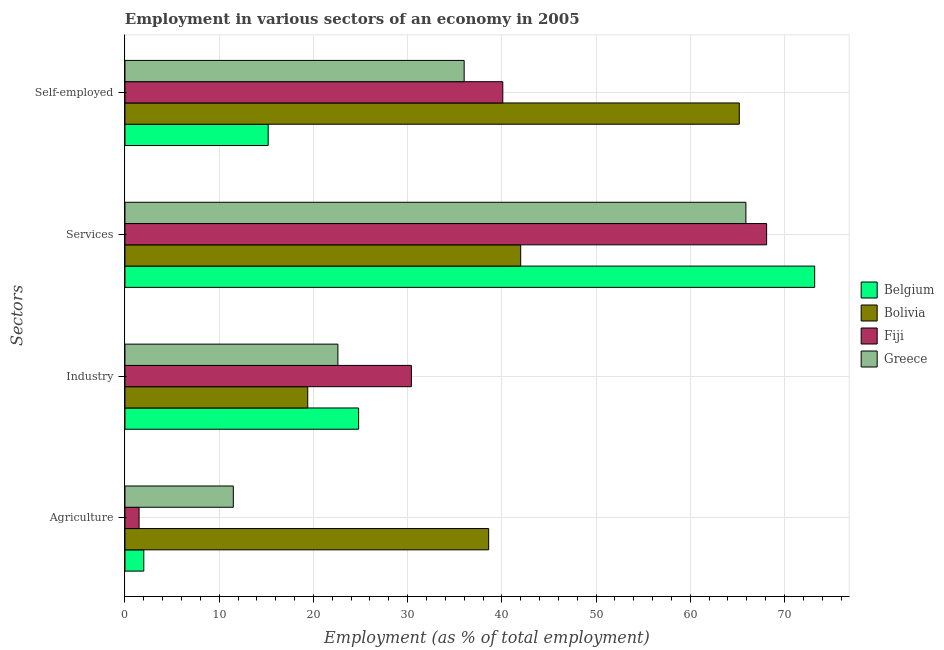Are the number of bars on each tick of the Y-axis equal?
Provide a succinct answer. Yes. How many bars are there on the 2nd tick from the top?
Ensure brevity in your answer.  4. What is the label of the 2nd group of bars from the top?
Your response must be concise. Services. What is the percentage of workers in industry in Greece?
Your response must be concise. 22.6. Across all countries, what is the maximum percentage of workers in industry?
Your response must be concise. 30.4. In which country was the percentage of workers in industry maximum?
Your response must be concise. Fiji. In which country was the percentage of workers in agriculture minimum?
Provide a short and direct response. Fiji. What is the total percentage of workers in agriculture in the graph?
Ensure brevity in your answer.  53.6. What is the difference between the percentage of self employed workers in Bolivia and that in Greece?
Offer a very short reply. 29.2. What is the difference between the percentage of workers in industry in Belgium and the percentage of workers in services in Fiji?
Keep it short and to the point. -43.3. What is the average percentage of workers in services per country?
Your response must be concise. 62.3. What is the difference between the percentage of workers in industry and percentage of self employed workers in Bolivia?
Ensure brevity in your answer.  -45.8. What is the ratio of the percentage of workers in industry in Bolivia to that in Greece?
Keep it short and to the point. 0.86. What is the difference between the highest and the second highest percentage of workers in services?
Give a very brief answer. 5.1. What is the difference between the highest and the lowest percentage of workers in agriculture?
Your answer should be compact. 37.1. In how many countries, is the percentage of workers in agriculture greater than the average percentage of workers in agriculture taken over all countries?
Ensure brevity in your answer.  1. Is the sum of the percentage of self employed workers in Greece and Bolivia greater than the maximum percentage of workers in services across all countries?
Keep it short and to the point. Yes. Is it the case that in every country, the sum of the percentage of workers in agriculture and percentage of workers in industry is greater than the sum of percentage of self employed workers and percentage of workers in services?
Keep it short and to the point. No. What does the 3rd bar from the bottom in Self-employed represents?
Ensure brevity in your answer.  Fiji. Are the values on the major ticks of X-axis written in scientific E-notation?
Give a very brief answer. No. Does the graph contain any zero values?
Your answer should be compact. No. Where does the legend appear in the graph?
Offer a very short reply. Center right. What is the title of the graph?
Provide a succinct answer. Employment in various sectors of an economy in 2005. Does "Puerto Rico" appear as one of the legend labels in the graph?
Make the answer very short. No. What is the label or title of the X-axis?
Keep it short and to the point. Employment (as % of total employment). What is the label or title of the Y-axis?
Provide a short and direct response. Sectors. What is the Employment (as % of total employment) in Bolivia in Agriculture?
Make the answer very short. 38.6. What is the Employment (as % of total employment) of Belgium in Industry?
Give a very brief answer. 24.8. What is the Employment (as % of total employment) of Bolivia in Industry?
Offer a terse response. 19.4. What is the Employment (as % of total employment) in Fiji in Industry?
Keep it short and to the point. 30.4. What is the Employment (as % of total employment) of Greece in Industry?
Provide a succinct answer. 22.6. What is the Employment (as % of total employment) in Belgium in Services?
Provide a succinct answer. 73.2. What is the Employment (as % of total employment) in Bolivia in Services?
Your response must be concise. 42. What is the Employment (as % of total employment) of Fiji in Services?
Your answer should be compact. 68.1. What is the Employment (as % of total employment) in Greece in Services?
Provide a short and direct response. 65.9. What is the Employment (as % of total employment) in Belgium in Self-employed?
Your response must be concise. 15.2. What is the Employment (as % of total employment) in Bolivia in Self-employed?
Your answer should be very brief. 65.2. What is the Employment (as % of total employment) in Fiji in Self-employed?
Ensure brevity in your answer.  40.1. Across all Sectors, what is the maximum Employment (as % of total employment) in Belgium?
Your response must be concise. 73.2. Across all Sectors, what is the maximum Employment (as % of total employment) in Bolivia?
Your response must be concise. 65.2. Across all Sectors, what is the maximum Employment (as % of total employment) of Fiji?
Offer a terse response. 68.1. Across all Sectors, what is the maximum Employment (as % of total employment) of Greece?
Your answer should be compact. 65.9. Across all Sectors, what is the minimum Employment (as % of total employment) in Belgium?
Ensure brevity in your answer.  2. Across all Sectors, what is the minimum Employment (as % of total employment) in Bolivia?
Your answer should be very brief. 19.4. Across all Sectors, what is the minimum Employment (as % of total employment) in Fiji?
Provide a succinct answer. 1.5. Across all Sectors, what is the minimum Employment (as % of total employment) of Greece?
Make the answer very short. 11.5. What is the total Employment (as % of total employment) of Belgium in the graph?
Offer a very short reply. 115.2. What is the total Employment (as % of total employment) in Bolivia in the graph?
Keep it short and to the point. 165.2. What is the total Employment (as % of total employment) of Fiji in the graph?
Make the answer very short. 140.1. What is the total Employment (as % of total employment) of Greece in the graph?
Your answer should be compact. 136. What is the difference between the Employment (as % of total employment) of Belgium in Agriculture and that in Industry?
Provide a short and direct response. -22.8. What is the difference between the Employment (as % of total employment) of Fiji in Agriculture and that in Industry?
Your answer should be compact. -28.9. What is the difference between the Employment (as % of total employment) of Greece in Agriculture and that in Industry?
Your response must be concise. -11.1. What is the difference between the Employment (as % of total employment) of Belgium in Agriculture and that in Services?
Your answer should be compact. -71.2. What is the difference between the Employment (as % of total employment) in Bolivia in Agriculture and that in Services?
Offer a terse response. -3.4. What is the difference between the Employment (as % of total employment) of Fiji in Agriculture and that in Services?
Give a very brief answer. -66.6. What is the difference between the Employment (as % of total employment) in Greece in Agriculture and that in Services?
Provide a succinct answer. -54.4. What is the difference between the Employment (as % of total employment) in Belgium in Agriculture and that in Self-employed?
Keep it short and to the point. -13.2. What is the difference between the Employment (as % of total employment) in Bolivia in Agriculture and that in Self-employed?
Provide a succinct answer. -26.6. What is the difference between the Employment (as % of total employment) in Fiji in Agriculture and that in Self-employed?
Make the answer very short. -38.6. What is the difference between the Employment (as % of total employment) in Greece in Agriculture and that in Self-employed?
Offer a very short reply. -24.5. What is the difference between the Employment (as % of total employment) in Belgium in Industry and that in Services?
Make the answer very short. -48.4. What is the difference between the Employment (as % of total employment) in Bolivia in Industry and that in Services?
Your answer should be compact. -22.6. What is the difference between the Employment (as % of total employment) in Fiji in Industry and that in Services?
Give a very brief answer. -37.7. What is the difference between the Employment (as % of total employment) of Greece in Industry and that in Services?
Your answer should be compact. -43.3. What is the difference between the Employment (as % of total employment) of Bolivia in Industry and that in Self-employed?
Offer a terse response. -45.8. What is the difference between the Employment (as % of total employment) in Greece in Industry and that in Self-employed?
Give a very brief answer. -13.4. What is the difference between the Employment (as % of total employment) of Bolivia in Services and that in Self-employed?
Your response must be concise. -23.2. What is the difference between the Employment (as % of total employment) in Greece in Services and that in Self-employed?
Your response must be concise. 29.9. What is the difference between the Employment (as % of total employment) in Belgium in Agriculture and the Employment (as % of total employment) in Bolivia in Industry?
Offer a terse response. -17.4. What is the difference between the Employment (as % of total employment) of Belgium in Agriculture and the Employment (as % of total employment) of Fiji in Industry?
Give a very brief answer. -28.4. What is the difference between the Employment (as % of total employment) in Belgium in Agriculture and the Employment (as % of total employment) in Greece in Industry?
Your response must be concise. -20.6. What is the difference between the Employment (as % of total employment) of Fiji in Agriculture and the Employment (as % of total employment) of Greece in Industry?
Keep it short and to the point. -21.1. What is the difference between the Employment (as % of total employment) of Belgium in Agriculture and the Employment (as % of total employment) of Bolivia in Services?
Ensure brevity in your answer.  -40. What is the difference between the Employment (as % of total employment) of Belgium in Agriculture and the Employment (as % of total employment) of Fiji in Services?
Offer a terse response. -66.1. What is the difference between the Employment (as % of total employment) of Belgium in Agriculture and the Employment (as % of total employment) of Greece in Services?
Your response must be concise. -63.9. What is the difference between the Employment (as % of total employment) of Bolivia in Agriculture and the Employment (as % of total employment) of Fiji in Services?
Make the answer very short. -29.5. What is the difference between the Employment (as % of total employment) of Bolivia in Agriculture and the Employment (as % of total employment) of Greece in Services?
Your answer should be very brief. -27.3. What is the difference between the Employment (as % of total employment) of Fiji in Agriculture and the Employment (as % of total employment) of Greece in Services?
Offer a terse response. -64.4. What is the difference between the Employment (as % of total employment) of Belgium in Agriculture and the Employment (as % of total employment) of Bolivia in Self-employed?
Your response must be concise. -63.2. What is the difference between the Employment (as % of total employment) of Belgium in Agriculture and the Employment (as % of total employment) of Fiji in Self-employed?
Your answer should be compact. -38.1. What is the difference between the Employment (as % of total employment) in Belgium in Agriculture and the Employment (as % of total employment) in Greece in Self-employed?
Give a very brief answer. -34. What is the difference between the Employment (as % of total employment) in Fiji in Agriculture and the Employment (as % of total employment) in Greece in Self-employed?
Offer a very short reply. -34.5. What is the difference between the Employment (as % of total employment) of Belgium in Industry and the Employment (as % of total employment) of Bolivia in Services?
Offer a terse response. -17.2. What is the difference between the Employment (as % of total employment) in Belgium in Industry and the Employment (as % of total employment) in Fiji in Services?
Provide a succinct answer. -43.3. What is the difference between the Employment (as % of total employment) of Belgium in Industry and the Employment (as % of total employment) of Greece in Services?
Provide a succinct answer. -41.1. What is the difference between the Employment (as % of total employment) in Bolivia in Industry and the Employment (as % of total employment) in Fiji in Services?
Ensure brevity in your answer.  -48.7. What is the difference between the Employment (as % of total employment) in Bolivia in Industry and the Employment (as % of total employment) in Greece in Services?
Make the answer very short. -46.5. What is the difference between the Employment (as % of total employment) of Fiji in Industry and the Employment (as % of total employment) of Greece in Services?
Your answer should be compact. -35.5. What is the difference between the Employment (as % of total employment) in Belgium in Industry and the Employment (as % of total employment) in Bolivia in Self-employed?
Your response must be concise. -40.4. What is the difference between the Employment (as % of total employment) in Belgium in Industry and the Employment (as % of total employment) in Fiji in Self-employed?
Make the answer very short. -15.3. What is the difference between the Employment (as % of total employment) in Bolivia in Industry and the Employment (as % of total employment) in Fiji in Self-employed?
Offer a very short reply. -20.7. What is the difference between the Employment (as % of total employment) of Bolivia in Industry and the Employment (as % of total employment) of Greece in Self-employed?
Your answer should be very brief. -16.6. What is the difference between the Employment (as % of total employment) of Belgium in Services and the Employment (as % of total employment) of Fiji in Self-employed?
Ensure brevity in your answer.  33.1. What is the difference between the Employment (as % of total employment) in Belgium in Services and the Employment (as % of total employment) in Greece in Self-employed?
Your response must be concise. 37.2. What is the difference between the Employment (as % of total employment) in Bolivia in Services and the Employment (as % of total employment) in Greece in Self-employed?
Offer a very short reply. 6. What is the difference between the Employment (as % of total employment) of Fiji in Services and the Employment (as % of total employment) of Greece in Self-employed?
Your answer should be compact. 32.1. What is the average Employment (as % of total employment) of Belgium per Sectors?
Your response must be concise. 28.8. What is the average Employment (as % of total employment) of Bolivia per Sectors?
Your answer should be compact. 41.3. What is the average Employment (as % of total employment) of Fiji per Sectors?
Ensure brevity in your answer.  35.02. What is the average Employment (as % of total employment) in Greece per Sectors?
Keep it short and to the point. 34. What is the difference between the Employment (as % of total employment) in Belgium and Employment (as % of total employment) in Bolivia in Agriculture?
Offer a terse response. -36.6. What is the difference between the Employment (as % of total employment) of Belgium and Employment (as % of total employment) of Fiji in Agriculture?
Offer a very short reply. 0.5. What is the difference between the Employment (as % of total employment) in Belgium and Employment (as % of total employment) in Greece in Agriculture?
Your answer should be very brief. -9.5. What is the difference between the Employment (as % of total employment) in Bolivia and Employment (as % of total employment) in Fiji in Agriculture?
Keep it short and to the point. 37.1. What is the difference between the Employment (as % of total employment) of Bolivia and Employment (as % of total employment) of Greece in Agriculture?
Your answer should be compact. 27.1. What is the difference between the Employment (as % of total employment) in Bolivia and Employment (as % of total employment) in Greece in Industry?
Your answer should be compact. -3.2. What is the difference between the Employment (as % of total employment) of Fiji and Employment (as % of total employment) of Greece in Industry?
Keep it short and to the point. 7.8. What is the difference between the Employment (as % of total employment) in Belgium and Employment (as % of total employment) in Bolivia in Services?
Offer a very short reply. 31.2. What is the difference between the Employment (as % of total employment) in Belgium and Employment (as % of total employment) in Greece in Services?
Give a very brief answer. 7.3. What is the difference between the Employment (as % of total employment) of Bolivia and Employment (as % of total employment) of Fiji in Services?
Offer a terse response. -26.1. What is the difference between the Employment (as % of total employment) in Bolivia and Employment (as % of total employment) in Greece in Services?
Your answer should be very brief. -23.9. What is the difference between the Employment (as % of total employment) of Fiji and Employment (as % of total employment) of Greece in Services?
Keep it short and to the point. 2.2. What is the difference between the Employment (as % of total employment) of Belgium and Employment (as % of total employment) of Fiji in Self-employed?
Ensure brevity in your answer.  -24.9. What is the difference between the Employment (as % of total employment) of Belgium and Employment (as % of total employment) of Greece in Self-employed?
Your response must be concise. -20.8. What is the difference between the Employment (as % of total employment) in Bolivia and Employment (as % of total employment) in Fiji in Self-employed?
Your answer should be compact. 25.1. What is the difference between the Employment (as % of total employment) in Bolivia and Employment (as % of total employment) in Greece in Self-employed?
Give a very brief answer. 29.2. What is the difference between the Employment (as % of total employment) of Fiji and Employment (as % of total employment) of Greece in Self-employed?
Give a very brief answer. 4.1. What is the ratio of the Employment (as % of total employment) of Belgium in Agriculture to that in Industry?
Offer a terse response. 0.08. What is the ratio of the Employment (as % of total employment) in Bolivia in Agriculture to that in Industry?
Give a very brief answer. 1.99. What is the ratio of the Employment (as % of total employment) in Fiji in Agriculture to that in Industry?
Keep it short and to the point. 0.05. What is the ratio of the Employment (as % of total employment) of Greece in Agriculture to that in Industry?
Your answer should be compact. 0.51. What is the ratio of the Employment (as % of total employment) in Belgium in Agriculture to that in Services?
Your answer should be very brief. 0.03. What is the ratio of the Employment (as % of total employment) of Bolivia in Agriculture to that in Services?
Your answer should be compact. 0.92. What is the ratio of the Employment (as % of total employment) in Fiji in Agriculture to that in Services?
Provide a short and direct response. 0.02. What is the ratio of the Employment (as % of total employment) of Greece in Agriculture to that in Services?
Your response must be concise. 0.17. What is the ratio of the Employment (as % of total employment) of Belgium in Agriculture to that in Self-employed?
Provide a succinct answer. 0.13. What is the ratio of the Employment (as % of total employment) of Bolivia in Agriculture to that in Self-employed?
Your answer should be very brief. 0.59. What is the ratio of the Employment (as % of total employment) in Fiji in Agriculture to that in Self-employed?
Provide a succinct answer. 0.04. What is the ratio of the Employment (as % of total employment) in Greece in Agriculture to that in Self-employed?
Provide a succinct answer. 0.32. What is the ratio of the Employment (as % of total employment) in Belgium in Industry to that in Services?
Ensure brevity in your answer.  0.34. What is the ratio of the Employment (as % of total employment) in Bolivia in Industry to that in Services?
Provide a short and direct response. 0.46. What is the ratio of the Employment (as % of total employment) of Fiji in Industry to that in Services?
Your answer should be very brief. 0.45. What is the ratio of the Employment (as % of total employment) of Greece in Industry to that in Services?
Your answer should be very brief. 0.34. What is the ratio of the Employment (as % of total employment) in Belgium in Industry to that in Self-employed?
Make the answer very short. 1.63. What is the ratio of the Employment (as % of total employment) of Bolivia in Industry to that in Self-employed?
Provide a succinct answer. 0.3. What is the ratio of the Employment (as % of total employment) of Fiji in Industry to that in Self-employed?
Provide a succinct answer. 0.76. What is the ratio of the Employment (as % of total employment) in Greece in Industry to that in Self-employed?
Give a very brief answer. 0.63. What is the ratio of the Employment (as % of total employment) in Belgium in Services to that in Self-employed?
Keep it short and to the point. 4.82. What is the ratio of the Employment (as % of total employment) in Bolivia in Services to that in Self-employed?
Give a very brief answer. 0.64. What is the ratio of the Employment (as % of total employment) in Fiji in Services to that in Self-employed?
Give a very brief answer. 1.7. What is the ratio of the Employment (as % of total employment) of Greece in Services to that in Self-employed?
Ensure brevity in your answer.  1.83. What is the difference between the highest and the second highest Employment (as % of total employment) in Belgium?
Ensure brevity in your answer.  48.4. What is the difference between the highest and the second highest Employment (as % of total employment) in Bolivia?
Give a very brief answer. 23.2. What is the difference between the highest and the second highest Employment (as % of total employment) in Fiji?
Keep it short and to the point. 28. What is the difference between the highest and the second highest Employment (as % of total employment) of Greece?
Provide a short and direct response. 29.9. What is the difference between the highest and the lowest Employment (as % of total employment) of Belgium?
Offer a terse response. 71.2. What is the difference between the highest and the lowest Employment (as % of total employment) in Bolivia?
Provide a succinct answer. 45.8. What is the difference between the highest and the lowest Employment (as % of total employment) of Fiji?
Provide a succinct answer. 66.6. What is the difference between the highest and the lowest Employment (as % of total employment) of Greece?
Provide a short and direct response. 54.4. 